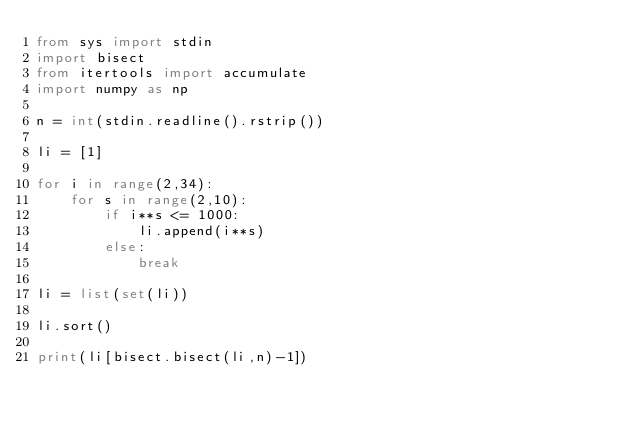<code> <loc_0><loc_0><loc_500><loc_500><_Python_>from sys import stdin
import bisect
from itertools import accumulate
import numpy as np

n = int(stdin.readline().rstrip())

li = [1]

for i in range(2,34):
    for s in range(2,10):
        if i**s <= 1000:
            li.append(i**s)
        else:
            break
    
li = list(set(li))

li.sort()

print(li[bisect.bisect(li,n)-1])</code> 